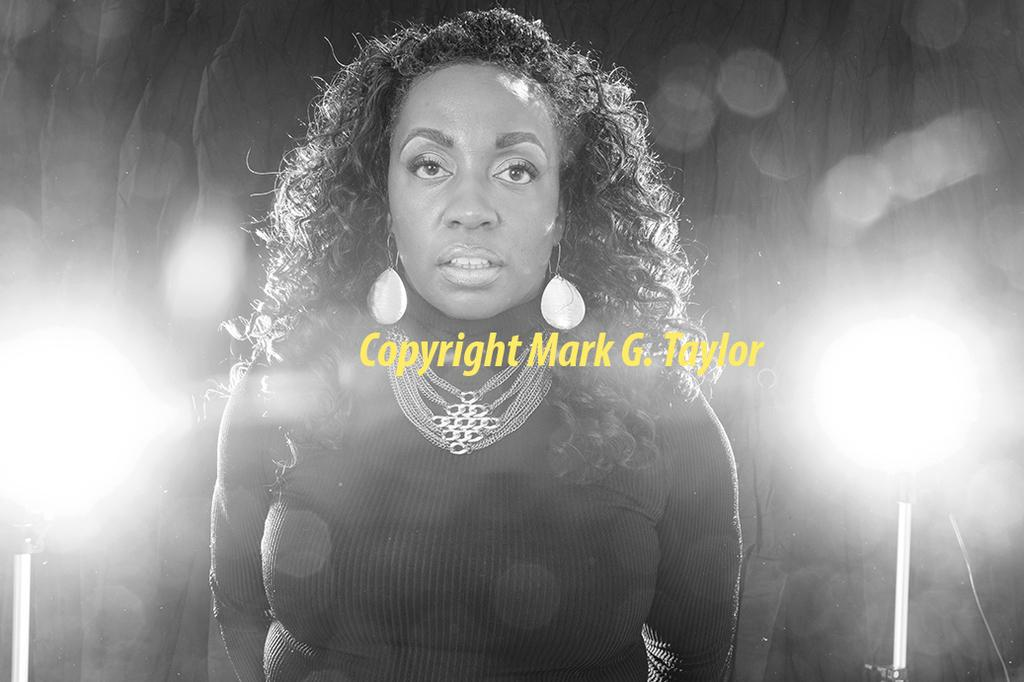Who is the main subject in the image? There is a woman in the image. What is the woman wearing? The woman is wearing a black dress and a necklace. What is the woman doing in the image? The woman is standing and posing for the camera. Can you describe the background of the image? There is a blurred background in the image, and spotlights are visible in the background. What month is the woman celebrating in the image? There is no indication of a specific month being celebrated in the image. What is the woman's relation to the person taking the photo? The provided facts do not give any information about the relationship between the woman and the person taking the photo. 